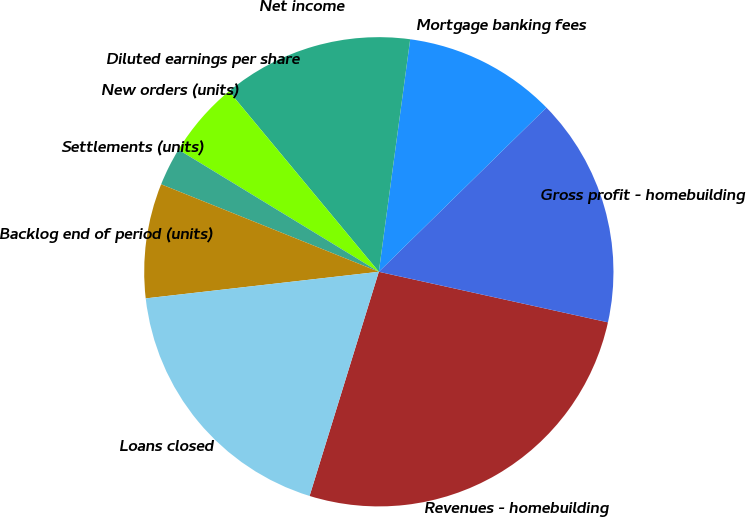Convert chart to OTSL. <chart><loc_0><loc_0><loc_500><loc_500><pie_chart><fcel>Revenues - homebuilding<fcel>Gross profit - homebuilding<fcel>Mortgage banking fees<fcel>Net income<fcel>Diluted earnings per share<fcel>New orders (units)<fcel>Settlements (units)<fcel>Backlog end of period (units)<fcel>Loans closed<nl><fcel>26.31%<fcel>15.79%<fcel>10.53%<fcel>13.16%<fcel>0.0%<fcel>5.26%<fcel>2.63%<fcel>7.89%<fcel>18.42%<nl></chart> 